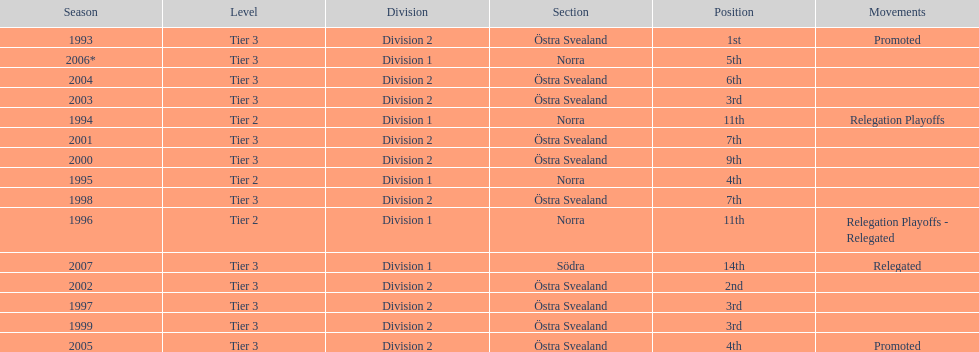In how many cases was norra noted as the section? 4. 